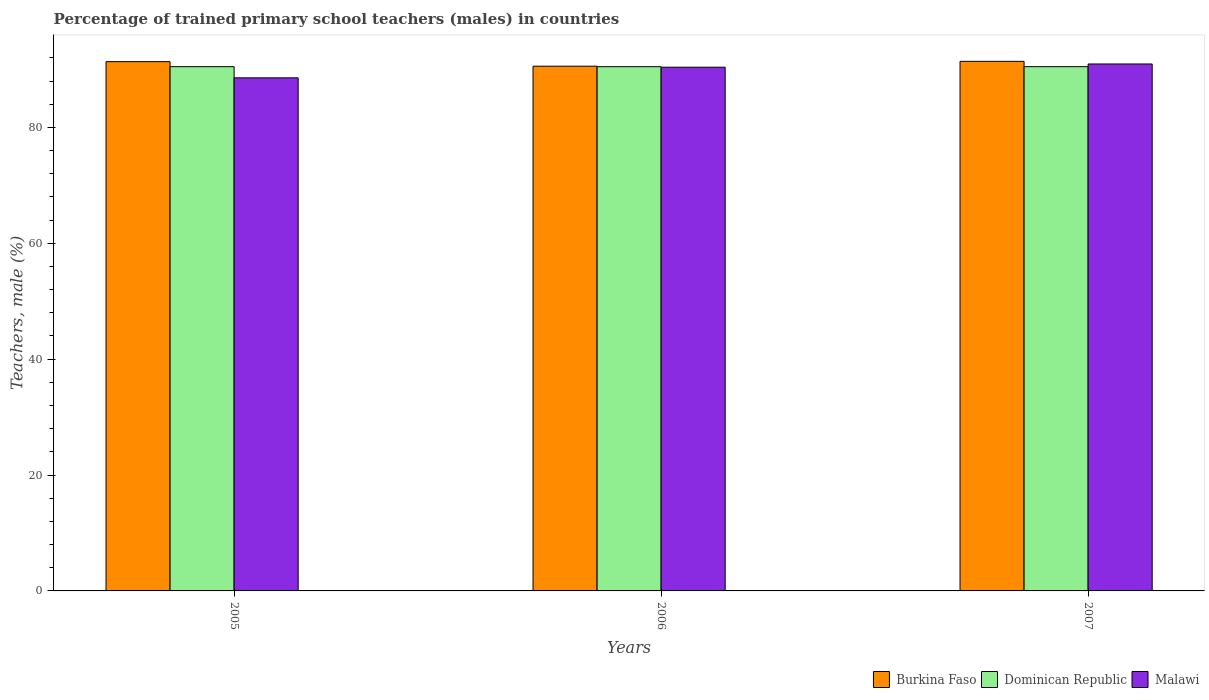How many groups of bars are there?
Give a very brief answer. 3. Are the number of bars on each tick of the X-axis equal?
Make the answer very short. Yes. How many bars are there on the 1st tick from the left?
Your answer should be very brief. 3. What is the label of the 3rd group of bars from the left?
Ensure brevity in your answer.  2007. In how many cases, is the number of bars for a given year not equal to the number of legend labels?
Offer a terse response. 0. What is the percentage of trained primary school teachers (males) in Malawi in 2006?
Keep it short and to the point. 90.39. Across all years, what is the maximum percentage of trained primary school teachers (males) in Burkina Faso?
Keep it short and to the point. 91.4. Across all years, what is the minimum percentage of trained primary school teachers (males) in Burkina Faso?
Provide a short and direct response. 90.57. In which year was the percentage of trained primary school teachers (males) in Malawi minimum?
Provide a succinct answer. 2005. What is the total percentage of trained primary school teachers (males) in Burkina Faso in the graph?
Make the answer very short. 273.32. What is the difference between the percentage of trained primary school teachers (males) in Burkina Faso in 2005 and that in 2006?
Provide a succinct answer. 0.78. What is the difference between the percentage of trained primary school teachers (males) in Malawi in 2007 and the percentage of trained primary school teachers (males) in Dominican Republic in 2005?
Keep it short and to the point. 0.46. What is the average percentage of trained primary school teachers (males) in Dominican Republic per year?
Your answer should be compact. 90.48. In the year 2006, what is the difference between the percentage of trained primary school teachers (males) in Burkina Faso and percentage of trained primary school teachers (males) in Malawi?
Your response must be concise. 0.18. What is the ratio of the percentage of trained primary school teachers (males) in Burkina Faso in 2005 to that in 2007?
Ensure brevity in your answer.  1. What is the difference between the highest and the second highest percentage of trained primary school teachers (males) in Burkina Faso?
Give a very brief answer. 0.05. What is the difference between the highest and the lowest percentage of trained primary school teachers (males) in Dominican Republic?
Your response must be concise. 0.01. What does the 3rd bar from the left in 2007 represents?
Your answer should be very brief. Malawi. What does the 1st bar from the right in 2006 represents?
Provide a succinct answer. Malawi. Is it the case that in every year, the sum of the percentage of trained primary school teachers (males) in Burkina Faso and percentage of trained primary school teachers (males) in Malawi is greater than the percentage of trained primary school teachers (males) in Dominican Republic?
Make the answer very short. Yes. Are the values on the major ticks of Y-axis written in scientific E-notation?
Offer a very short reply. No. Does the graph contain grids?
Offer a terse response. No. Where does the legend appear in the graph?
Ensure brevity in your answer.  Bottom right. How many legend labels are there?
Offer a terse response. 3. What is the title of the graph?
Your answer should be compact. Percentage of trained primary school teachers (males) in countries. What is the label or title of the Y-axis?
Your response must be concise. Teachers, male (%). What is the Teachers, male (%) of Burkina Faso in 2005?
Your answer should be compact. 91.35. What is the Teachers, male (%) in Dominican Republic in 2005?
Ensure brevity in your answer.  90.48. What is the Teachers, male (%) in Malawi in 2005?
Give a very brief answer. 88.56. What is the Teachers, male (%) in Burkina Faso in 2006?
Provide a short and direct response. 90.57. What is the Teachers, male (%) in Dominican Republic in 2006?
Keep it short and to the point. 90.48. What is the Teachers, male (%) of Malawi in 2006?
Your response must be concise. 90.39. What is the Teachers, male (%) of Burkina Faso in 2007?
Ensure brevity in your answer.  91.4. What is the Teachers, male (%) in Dominican Republic in 2007?
Offer a terse response. 90.49. What is the Teachers, male (%) of Malawi in 2007?
Give a very brief answer. 90.95. Across all years, what is the maximum Teachers, male (%) of Burkina Faso?
Your answer should be very brief. 91.4. Across all years, what is the maximum Teachers, male (%) of Dominican Republic?
Your answer should be compact. 90.49. Across all years, what is the maximum Teachers, male (%) of Malawi?
Offer a terse response. 90.95. Across all years, what is the minimum Teachers, male (%) in Burkina Faso?
Your response must be concise. 90.57. Across all years, what is the minimum Teachers, male (%) in Dominican Republic?
Keep it short and to the point. 90.48. Across all years, what is the minimum Teachers, male (%) of Malawi?
Make the answer very short. 88.56. What is the total Teachers, male (%) in Burkina Faso in the graph?
Your answer should be compact. 273.32. What is the total Teachers, male (%) in Dominican Republic in the graph?
Keep it short and to the point. 271.45. What is the total Teachers, male (%) in Malawi in the graph?
Provide a succinct answer. 269.9. What is the difference between the Teachers, male (%) in Burkina Faso in 2005 and that in 2006?
Offer a very short reply. 0.78. What is the difference between the Teachers, male (%) of Dominican Republic in 2005 and that in 2006?
Provide a short and direct response. 0.01. What is the difference between the Teachers, male (%) in Malawi in 2005 and that in 2006?
Provide a succinct answer. -1.83. What is the difference between the Teachers, male (%) of Burkina Faso in 2005 and that in 2007?
Give a very brief answer. -0.05. What is the difference between the Teachers, male (%) of Dominican Republic in 2005 and that in 2007?
Offer a terse response. -0. What is the difference between the Teachers, male (%) in Malawi in 2005 and that in 2007?
Provide a short and direct response. -2.39. What is the difference between the Teachers, male (%) of Burkina Faso in 2006 and that in 2007?
Make the answer very short. -0.83. What is the difference between the Teachers, male (%) in Dominican Republic in 2006 and that in 2007?
Your answer should be compact. -0.01. What is the difference between the Teachers, male (%) in Malawi in 2006 and that in 2007?
Your response must be concise. -0.56. What is the difference between the Teachers, male (%) of Burkina Faso in 2005 and the Teachers, male (%) of Dominican Republic in 2006?
Offer a very short reply. 0.87. What is the difference between the Teachers, male (%) in Burkina Faso in 2005 and the Teachers, male (%) in Malawi in 2006?
Make the answer very short. 0.96. What is the difference between the Teachers, male (%) of Dominican Republic in 2005 and the Teachers, male (%) of Malawi in 2006?
Offer a very short reply. 0.09. What is the difference between the Teachers, male (%) in Burkina Faso in 2005 and the Teachers, male (%) in Dominican Republic in 2007?
Your answer should be very brief. 0.87. What is the difference between the Teachers, male (%) in Burkina Faso in 2005 and the Teachers, male (%) in Malawi in 2007?
Offer a very short reply. 0.4. What is the difference between the Teachers, male (%) in Dominican Republic in 2005 and the Teachers, male (%) in Malawi in 2007?
Your answer should be very brief. -0.46. What is the difference between the Teachers, male (%) in Burkina Faso in 2006 and the Teachers, male (%) in Dominican Republic in 2007?
Provide a short and direct response. 0.08. What is the difference between the Teachers, male (%) in Burkina Faso in 2006 and the Teachers, male (%) in Malawi in 2007?
Offer a very short reply. -0.38. What is the difference between the Teachers, male (%) in Dominican Republic in 2006 and the Teachers, male (%) in Malawi in 2007?
Provide a short and direct response. -0.47. What is the average Teachers, male (%) in Burkina Faso per year?
Your answer should be very brief. 91.11. What is the average Teachers, male (%) in Dominican Republic per year?
Your answer should be very brief. 90.48. What is the average Teachers, male (%) of Malawi per year?
Offer a terse response. 89.97. In the year 2005, what is the difference between the Teachers, male (%) in Burkina Faso and Teachers, male (%) in Dominican Republic?
Offer a terse response. 0.87. In the year 2005, what is the difference between the Teachers, male (%) in Burkina Faso and Teachers, male (%) in Malawi?
Provide a short and direct response. 2.79. In the year 2005, what is the difference between the Teachers, male (%) of Dominican Republic and Teachers, male (%) of Malawi?
Make the answer very short. 1.93. In the year 2006, what is the difference between the Teachers, male (%) in Burkina Faso and Teachers, male (%) in Dominican Republic?
Your response must be concise. 0.09. In the year 2006, what is the difference between the Teachers, male (%) of Burkina Faso and Teachers, male (%) of Malawi?
Offer a terse response. 0.18. In the year 2006, what is the difference between the Teachers, male (%) in Dominican Republic and Teachers, male (%) in Malawi?
Provide a short and direct response. 0.09. In the year 2007, what is the difference between the Teachers, male (%) of Burkina Faso and Teachers, male (%) of Dominican Republic?
Keep it short and to the point. 0.92. In the year 2007, what is the difference between the Teachers, male (%) in Burkina Faso and Teachers, male (%) in Malawi?
Provide a short and direct response. 0.45. In the year 2007, what is the difference between the Teachers, male (%) of Dominican Republic and Teachers, male (%) of Malawi?
Give a very brief answer. -0.46. What is the ratio of the Teachers, male (%) of Burkina Faso in 2005 to that in 2006?
Your answer should be compact. 1.01. What is the ratio of the Teachers, male (%) in Dominican Republic in 2005 to that in 2006?
Your answer should be compact. 1. What is the ratio of the Teachers, male (%) of Malawi in 2005 to that in 2006?
Your answer should be compact. 0.98. What is the ratio of the Teachers, male (%) of Burkina Faso in 2005 to that in 2007?
Offer a terse response. 1. What is the ratio of the Teachers, male (%) of Malawi in 2005 to that in 2007?
Your answer should be very brief. 0.97. What is the ratio of the Teachers, male (%) of Burkina Faso in 2006 to that in 2007?
Give a very brief answer. 0.99. What is the ratio of the Teachers, male (%) in Dominican Republic in 2006 to that in 2007?
Provide a succinct answer. 1. What is the difference between the highest and the second highest Teachers, male (%) in Burkina Faso?
Give a very brief answer. 0.05. What is the difference between the highest and the second highest Teachers, male (%) in Dominican Republic?
Offer a terse response. 0. What is the difference between the highest and the second highest Teachers, male (%) of Malawi?
Your response must be concise. 0.56. What is the difference between the highest and the lowest Teachers, male (%) in Burkina Faso?
Ensure brevity in your answer.  0.83. What is the difference between the highest and the lowest Teachers, male (%) of Dominican Republic?
Provide a succinct answer. 0.01. What is the difference between the highest and the lowest Teachers, male (%) in Malawi?
Make the answer very short. 2.39. 